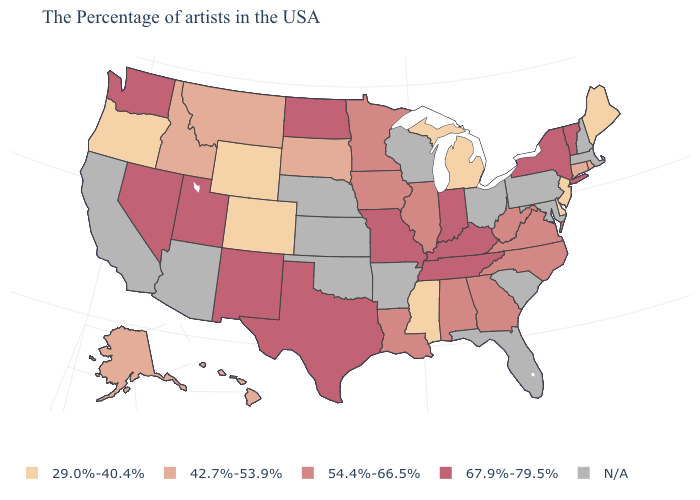Is the legend a continuous bar?
Be succinct. No. Name the states that have a value in the range 54.4%-66.5%?
Quick response, please. Virginia, North Carolina, West Virginia, Georgia, Alabama, Illinois, Louisiana, Minnesota, Iowa. What is the value of Connecticut?
Give a very brief answer. 42.7%-53.9%. How many symbols are there in the legend?
Give a very brief answer. 5. What is the value of Rhode Island?
Keep it brief. 42.7%-53.9%. Among the states that border Connecticut , which have the highest value?
Short answer required. New York. Which states have the lowest value in the USA?
Give a very brief answer. Maine, New Jersey, Delaware, Michigan, Mississippi, Wyoming, Colorado, Oregon. Does Michigan have the lowest value in the MidWest?
Concise answer only. Yes. Which states have the highest value in the USA?
Concise answer only. Vermont, New York, Kentucky, Indiana, Tennessee, Missouri, Texas, North Dakota, New Mexico, Utah, Nevada, Washington. Name the states that have a value in the range 42.7%-53.9%?
Write a very short answer. Rhode Island, Connecticut, South Dakota, Montana, Idaho, Alaska, Hawaii. What is the value of North Carolina?
Short answer required. 54.4%-66.5%. What is the value of Maryland?
Keep it brief. N/A. What is the highest value in the USA?
Give a very brief answer. 67.9%-79.5%. 